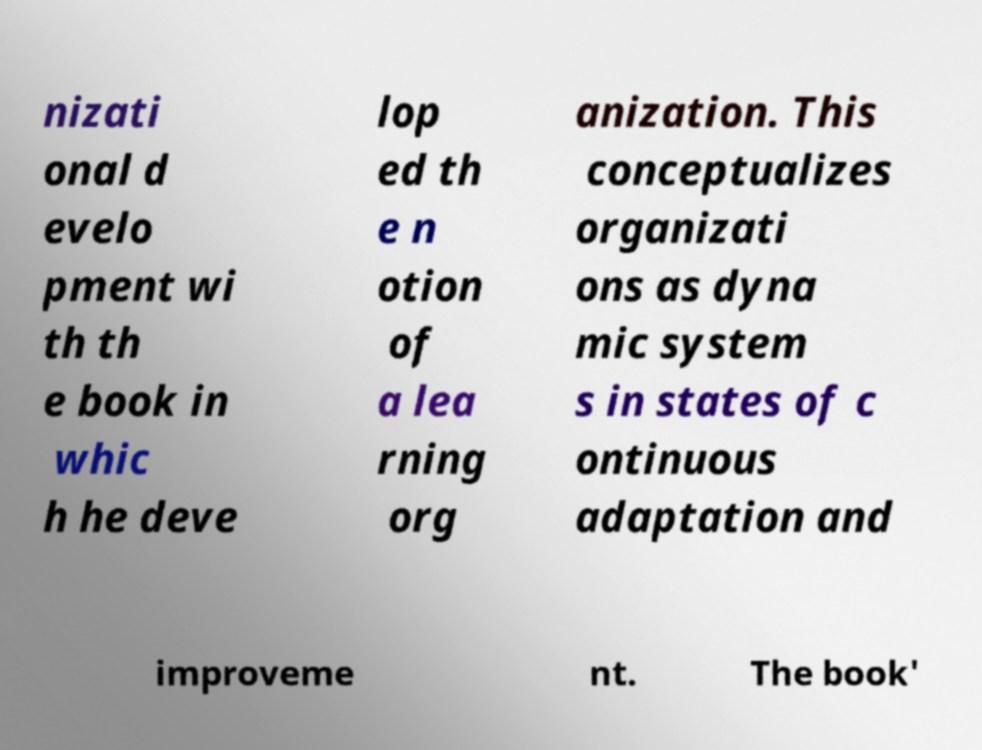I need the written content from this picture converted into text. Can you do that? nizati onal d evelo pment wi th th e book in whic h he deve lop ed th e n otion of a lea rning org anization. This conceptualizes organizati ons as dyna mic system s in states of c ontinuous adaptation and improveme nt. The book' 